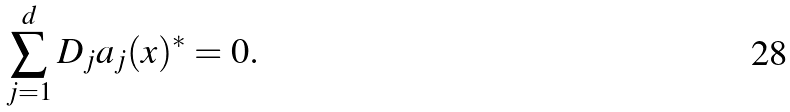<formula> <loc_0><loc_0><loc_500><loc_500>\sum _ { j = 1 } ^ { d } D _ { j } a _ { j } ( x ) ^ { * } = 0 .</formula> 